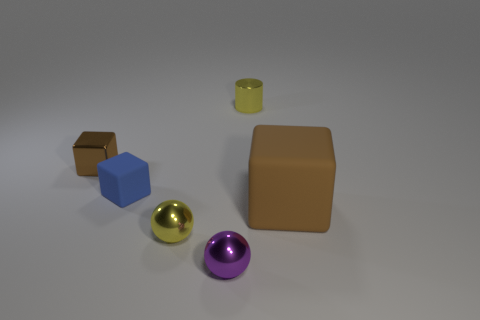How many objects are tiny yellow metal things behind the brown rubber block or cyan metal cubes? In the image, there is a single tiny yellow metal object behind the brown rubber block. There are no cyan metal cubes present. 